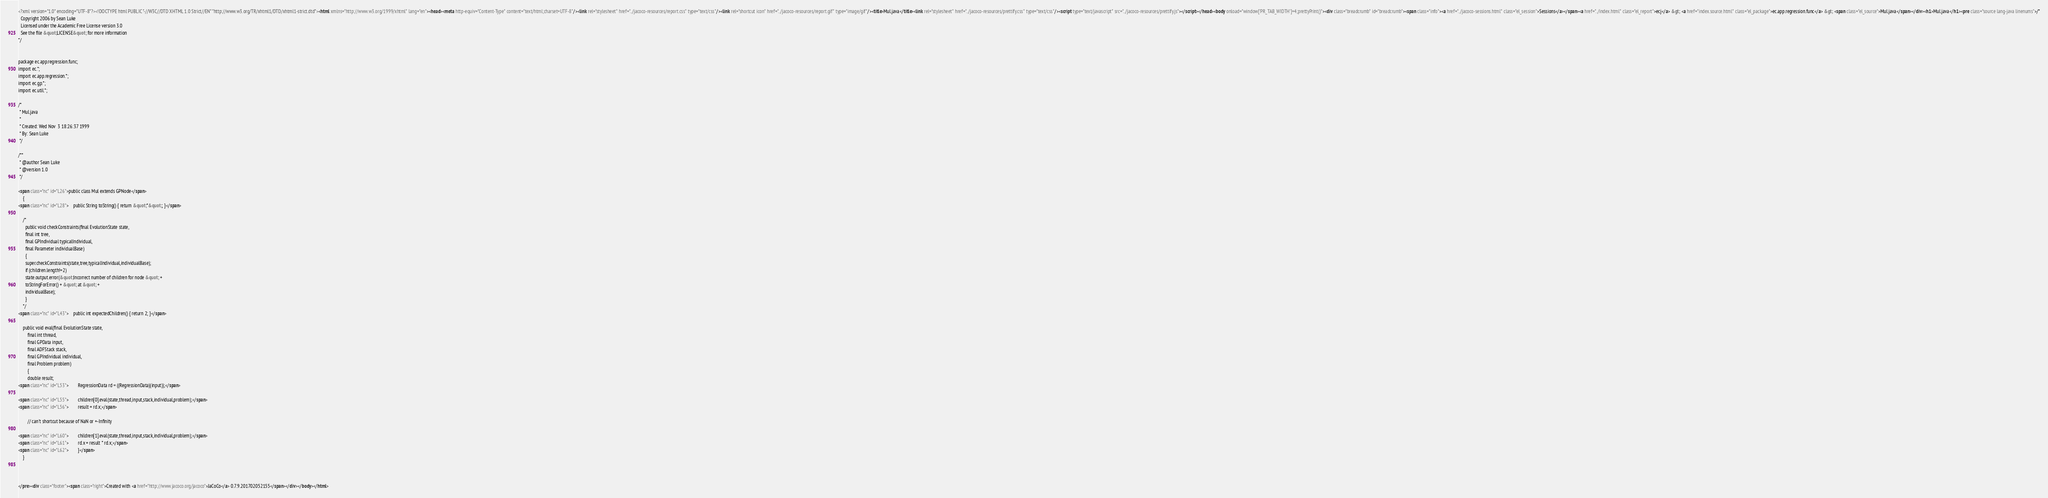<code> <loc_0><loc_0><loc_500><loc_500><_HTML_><?xml version="1.0" encoding="UTF-8"?><!DOCTYPE html PUBLIC "-//W3C//DTD XHTML 1.0 Strict//EN" "http://www.w3.org/TR/xhtml1/DTD/xhtml1-strict.dtd"><html xmlns="http://www.w3.org/1999/xhtml" lang="en"><head><meta http-equiv="Content-Type" content="text/html;charset=UTF-8"/><link rel="stylesheet" href="../jacoco-resources/report.css" type="text/css"/><link rel="shortcut icon" href="../jacoco-resources/report.gif" type="image/gif"/><title>Mul.java</title><link rel="stylesheet" href="../jacoco-resources/prettify.css" type="text/css"/><script type="text/javascript" src="../jacoco-resources/prettify.js"></script></head><body onload="window['PR_TAB_WIDTH']=4;prettyPrint()"><div class="breadcrumb" id="breadcrumb"><span class="info"><a href="../jacoco-sessions.html" class="el_session">Sessions</a></span><a href="../index.html" class="el_report">ecj</a> &gt; <a href="index.source.html" class="el_package">ec.app.regression.func</a> &gt; <span class="el_source">Mul.java</span></div><h1>Mul.java</h1><pre class="source lang-java linenums">/*
  Copyright 2006 by Sean Luke
  Licensed under the Academic Free License version 3.0
  See the file &quot;LICENSE&quot; for more information
*/


package ec.app.regression.func;
import ec.*;
import ec.app.regression.*;
import ec.gp.*;
import ec.util.*;

/* 
 * Mul.java
 * 
 * Created: Wed Nov  3 18:26:37 1999
 * By: Sean Luke
 */

/**
 * @author Sean Luke
 * @version 1.0 
 */

<span class="nc" id="L26">public class Mul extends GPNode</span>
    {
<span class="nc" id="L28">    public String toString() { return &quot;*&quot;; }</span>

    /*
      public void checkConstraints(final EvolutionState state,
      final int tree,
      final GPIndividual typicalIndividual,
      final Parameter individualBase)
      {
      super.checkConstraints(state,tree,typicalIndividual,individualBase);
      if (children.length!=2)
      state.output.error(&quot;Incorrect number of children for node &quot; + 
      toStringForError() + &quot; at &quot; +
      individualBase);
      }
    */
<span class="nc" id="L43">    public int expectedChildren() { return 2; }</span>

    public void eval(final EvolutionState state,
        final int thread,
        final GPData input,
        final ADFStack stack,
        final GPIndividual individual,
        final Problem problem)
        {
        double result;
<span class="nc" id="L53">        RegressionData rd = ((RegressionData)(input));</span>

<span class="nc" id="L55">        children[0].eval(state,thread,input,stack,individual,problem);</span>
<span class="nc" id="L56">        result = rd.x;</span>

        // can't shortcut because of NaN or +-Infinity

<span class="nc" id="L60">        children[1].eval(state,thread,input,stack,individual,problem);</span>
<span class="nc" id="L61">        rd.x = result * rd.x;</span>
<span class="nc" id="L62">        }</span>
    }



</pre><div class="footer"><span class="right">Created with <a href="http://www.jacoco.org/jacoco">JaCoCo</a> 0.7.9.201702052155</span></div></body></html></code> 